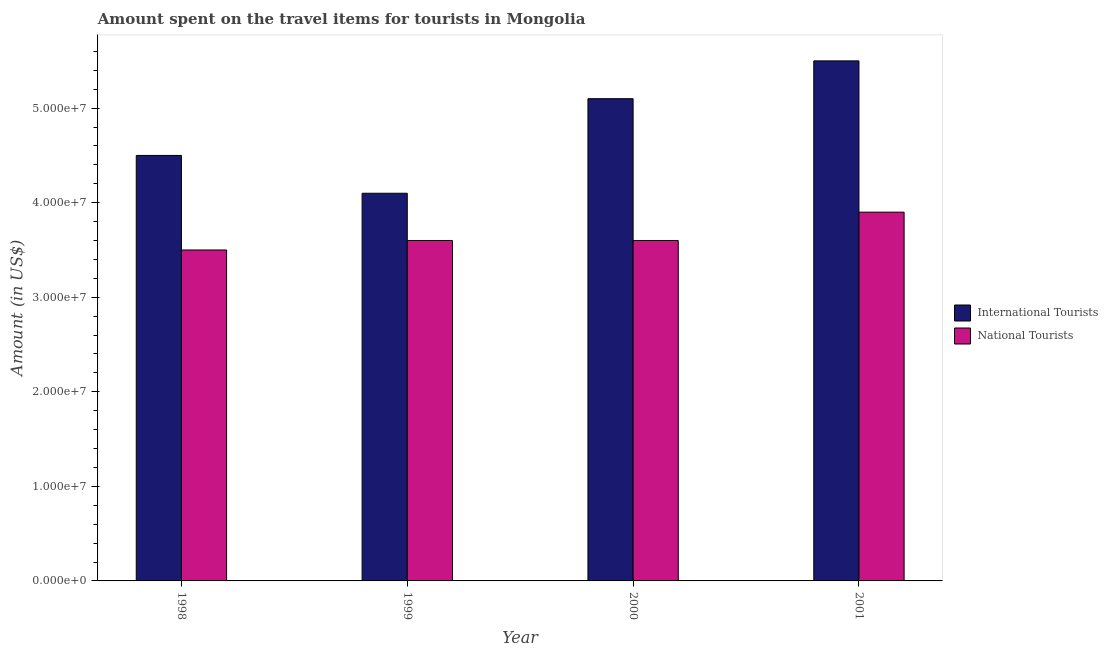How many different coloured bars are there?
Make the answer very short. 2. How many groups of bars are there?
Offer a very short reply. 4. Are the number of bars per tick equal to the number of legend labels?
Your answer should be very brief. Yes. Are the number of bars on each tick of the X-axis equal?
Give a very brief answer. Yes. How many bars are there on the 2nd tick from the left?
Give a very brief answer. 2. What is the amount spent on travel items of national tourists in 2000?
Provide a short and direct response. 3.60e+07. Across all years, what is the maximum amount spent on travel items of international tourists?
Keep it short and to the point. 5.50e+07. Across all years, what is the minimum amount spent on travel items of national tourists?
Give a very brief answer. 3.50e+07. In which year was the amount spent on travel items of international tourists maximum?
Your answer should be very brief. 2001. In which year was the amount spent on travel items of national tourists minimum?
Provide a succinct answer. 1998. What is the total amount spent on travel items of international tourists in the graph?
Provide a succinct answer. 1.92e+08. What is the difference between the amount spent on travel items of international tourists in 1998 and that in 2000?
Give a very brief answer. -6.00e+06. What is the difference between the amount spent on travel items of international tourists in 2000 and the amount spent on travel items of national tourists in 1999?
Your answer should be compact. 1.00e+07. What is the average amount spent on travel items of international tourists per year?
Provide a short and direct response. 4.80e+07. In the year 1999, what is the difference between the amount spent on travel items of international tourists and amount spent on travel items of national tourists?
Provide a short and direct response. 0. What is the ratio of the amount spent on travel items of national tourists in 1999 to that in 2000?
Offer a very short reply. 1. Is the amount spent on travel items of national tourists in 1998 less than that in 2000?
Ensure brevity in your answer.  Yes. Is the difference between the amount spent on travel items of national tourists in 1999 and 2001 greater than the difference between the amount spent on travel items of international tourists in 1999 and 2001?
Your answer should be compact. No. What is the difference between the highest and the second highest amount spent on travel items of international tourists?
Give a very brief answer. 4.00e+06. What is the difference between the highest and the lowest amount spent on travel items of international tourists?
Your answer should be compact. 1.40e+07. In how many years, is the amount spent on travel items of national tourists greater than the average amount spent on travel items of national tourists taken over all years?
Give a very brief answer. 1. Is the sum of the amount spent on travel items of international tourists in 1998 and 2000 greater than the maximum amount spent on travel items of national tourists across all years?
Your response must be concise. Yes. What does the 1st bar from the left in 1998 represents?
Make the answer very short. International Tourists. What does the 1st bar from the right in 2000 represents?
Your response must be concise. National Tourists. Are all the bars in the graph horizontal?
Keep it short and to the point. No. How many years are there in the graph?
Your response must be concise. 4. Does the graph contain grids?
Your answer should be compact. No. Where does the legend appear in the graph?
Provide a succinct answer. Center right. How many legend labels are there?
Offer a very short reply. 2. How are the legend labels stacked?
Offer a very short reply. Vertical. What is the title of the graph?
Offer a very short reply. Amount spent on the travel items for tourists in Mongolia. Does "Depositors" appear as one of the legend labels in the graph?
Your response must be concise. No. What is the label or title of the Y-axis?
Offer a very short reply. Amount (in US$). What is the Amount (in US$) of International Tourists in 1998?
Give a very brief answer. 4.50e+07. What is the Amount (in US$) of National Tourists in 1998?
Your answer should be compact. 3.50e+07. What is the Amount (in US$) in International Tourists in 1999?
Provide a short and direct response. 4.10e+07. What is the Amount (in US$) in National Tourists in 1999?
Provide a succinct answer. 3.60e+07. What is the Amount (in US$) of International Tourists in 2000?
Keep it short and to the point. 5.10e+07. What is the Amount (in US$) of National Tourists in 2000?
Ensure brevity in your answer.  3.60e+07. What is the Amount (in US$) in International Tourists in 2001?
Give a very brief answer. 5.50e+07. What is the Amount (in US$) in National Tourists in 2001?
Keep it short and to the point. 3.90e+07. Across all years, what is the maximum Amount (in US$) in International Tourists?
Your answer should be very brief. 5.50e+07. Across all years, what is the maximum Amount (in US$) in National Tourists?
Provide a short and direct response. 3.90e+07. Across all years, what is the minimum Amount (in US$) in International Tourists?
Your answer should be very brief. 4.10e+07. Across all years, what is the minimum Amount (in US$) of National Tourists?
Give a very brief answer. 3.50e+07. What is the total Amount (in US$) in International Tourists in the graph?
Your answer should be very brief. 1.92e+08. What is the total Amount (in US$) in National Tourists in the graph?
Provide a succinct answer. 1.46e+08. What is the difference between the Amount (in US$) of International Tourists in 1998 and that in 1999?
Your answer should be compact. 4.00e+06. What is the difference between the Amount (in US$) in National Tourists in 1998 and that in 1999?
Your answer should be very brief. -1.00e+06. What is the difference between the Amount (in US$) of International Tourists in 1998 and that in 2000?
Give a very brief answer. -6.00e+06. What is the difference between the Amount (in US$) in International Tourists in 1998 and that in 2001?
Provide a succinct answer. -1.00e+07. What is the difference between the Amount (in US$) in International Tourists in 1999 and that in 2000?
Your answer should be compact. -1.00e+07. What is the difference between the Amount (in US$) of International Tourists in 1999 and that in 2001?
Your answer should be compact. -1.40e+07. What is the difference between the Amount (in US$) of National Tourists in 2000 and that in 2001?
Your response must be concise. -3.00e+06. What is the difference between the Amount (in US$) in International Tourists in 1998 and the Amount (in US$) in National Tourists in 1999?
Offer a terse response. 9.00e+06. What is the difference between the Amount (in US$) of International Tourists in 1998 and the Amount (in US$) of National Tourists in 2000?
Your answer should be compact. 9.00e+06. What is the average Amount (in US$) in International Tourists per year?
Offer a terse response. 4.80e+07. What is the average Amount (in US$) in National Tourists per year?
Give a very brief answer. 3.65e+07. In the year 1998, what is the difference between the Amount (in US$) of International Tourists and Amount (in US$) of National Tourists?
Provide a short and direct response. 1.00e+07. In the year 2000, what is the difference between the Amount (in US$) in International Tourists and Amount (in US$) in National Tourists?
Provide a succinct answer. 1.50e+07. In the year 2001, what is the difference between the Amount (in US$) in International Tourists and Amount (in US$) in National Tourists?
Your answer should be very brief. 1.60e+07. What is the ratio of the Amount (in US$) in International Tourists in 1998 to that in 1999?
Your answer should be compact. 1.1. What is the ratio of the Amount (in US$) of National Tourists in 1998 to that in 1999?
Your answer should be very brief. 0.97. What is the ratio of the Amount (in US$) in International Tourists in 1998 to that in 2000?
Offer a very short reply. 0.88. What is the ratio of the Amount (in US$) of National Tourists in 1998 to that in 2000?
Offer a very short reply. 0.97. What is the ratio of the Amount (in US$) of International Tourists in 1998 to that in 2001?
Your response must be concise. 0.82. What is the ratio of the Amount (in US$) in National Tourists in 1998 to that in 2001?
Your answer should be very brief. 0.9. What is the ratio of the Amount (in US$) of International Tourists in 1999 to that in 2000?
Your response must be concise. 0.8. What is the ratio of the Amount (in US$) of National Tourists in 1999 to that in 2000?
Provide a succinct answer. 1. What is the ratio of the Amount (in US$) of International Tourists in 1999 to that in 2001?
Your answer should be very brief. 0.75. What is the ratio of the Amount (in US$) of International Tourists in 2000 to that in 2001?
Your answer should be compact. 0.93. What is the ratio of the Amount (in US$) in National Tourists in 2000 to that in 2001?
Make the answer very short. 0.92. What is the difference between the highest and the second highest Amount (in US$) in International Tourists?
Keep it short and to the point. 4.00e+06. What is the difference between the highest and the second highest Amount (in US$) of National Tourists?
Make the answer very short. 3.00e+06. What is the difference between the highest and the lowest Amount (in US$) in International Tourists?
Your answer should be very brief. 1.40e+07. 